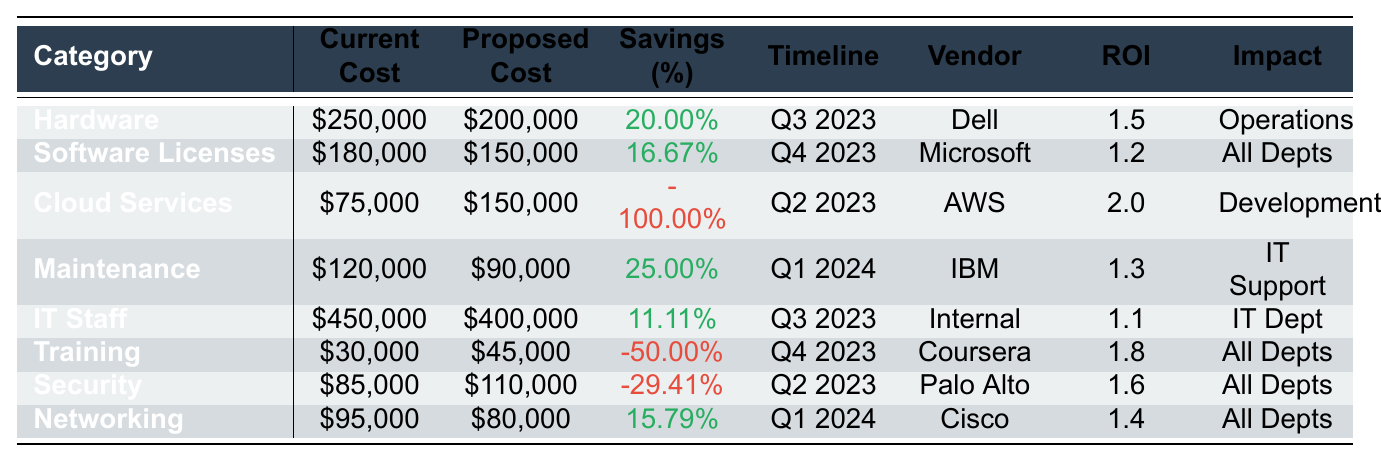What is the proposed cost for Cloud Services? The table lists the proposed cost for Cloud Services as $150,000.
Answer: $150,000 What percentage savings is expected for Hardware? The expected savings percentage for Hardware is 20.00%, as listed in the table.
Answer: 20.00% Which category has the highest current cost? The category with the highest current cost is IT Staff, totaling $450,000 according to the table.
Answer: IT Staff What is the ROI for the Software Licenses category? The ROI for Software Licenses is 1.2, as shown in the table.
Answer: 1.2 What is the total savings percentage across all categories? The total savings percentage needs to be computed from each category: (20 + 16.67 + (-100) + 25 + 11.11 + (-50) + (-29.41) + 15.79) = -10.84%.
Answer: -10.84% Are there any categories with negative savings percentages? Yes, Cloud Services, Training, and Security all have negative savings percentages, indicating an increase in costs.
Answer: Yes What is the timeline for implementing the Networking category? According to the table, the timeline for Networking is Q1 2024.
Answer: Q1 2024 How much is the difference in proposed and current costs for the Maintenance category? The difference is calculated as $120,000 (current) - $90,000 (proposed) = $30,000 savings.
Answer: $30,000 Is the proposed cost for Training higher than the current cost? Yes, the proposed cost for Training is $45,000, which is higher than the current cost of $30,000.
Answer: Yes Which vendor is associated with the highest ROI? The highest ROI is associated with Cloud Services, with an ROI of 2.0 as per the table.
Answer: Amazon Web Services 